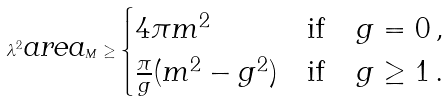Convert formula to latex. <formula><loc_0><loc_0><loc_500><loc_500>\lambda ^ { 2 } \text {\em area} _ { M } \geq \begin{cases} 4 \pi m ^ { 2 } & \text {if} \quad g = 0 \, , \\ \frac { \pi } { g } ( m ^ { 2 } - g ^ { 2 } ) & \text {if} \quad g \geq 1 \, . \end{cases}</formula> 